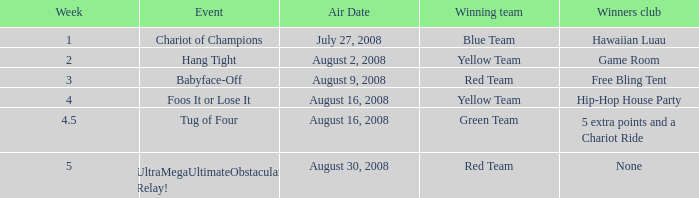Which successful club features a 5 extra points and a Chariot Ride. 